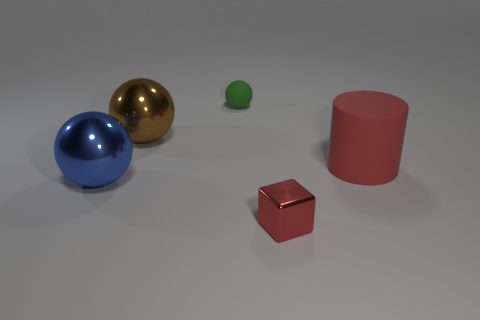Add 1 gray matte things. How many objects exist? 6 Subtract all cubes. How many objects are left? 4 Add 1 large brown objects. How many large brown objects are left? 2 Add 5 green metallic cylinders. How many green metallic cylinders exist? 5 Subtract 0 green cubes. How many objects are left? 5 Subtract all shiny things. Subtract all blue metal balls. How many objects are left? 1 